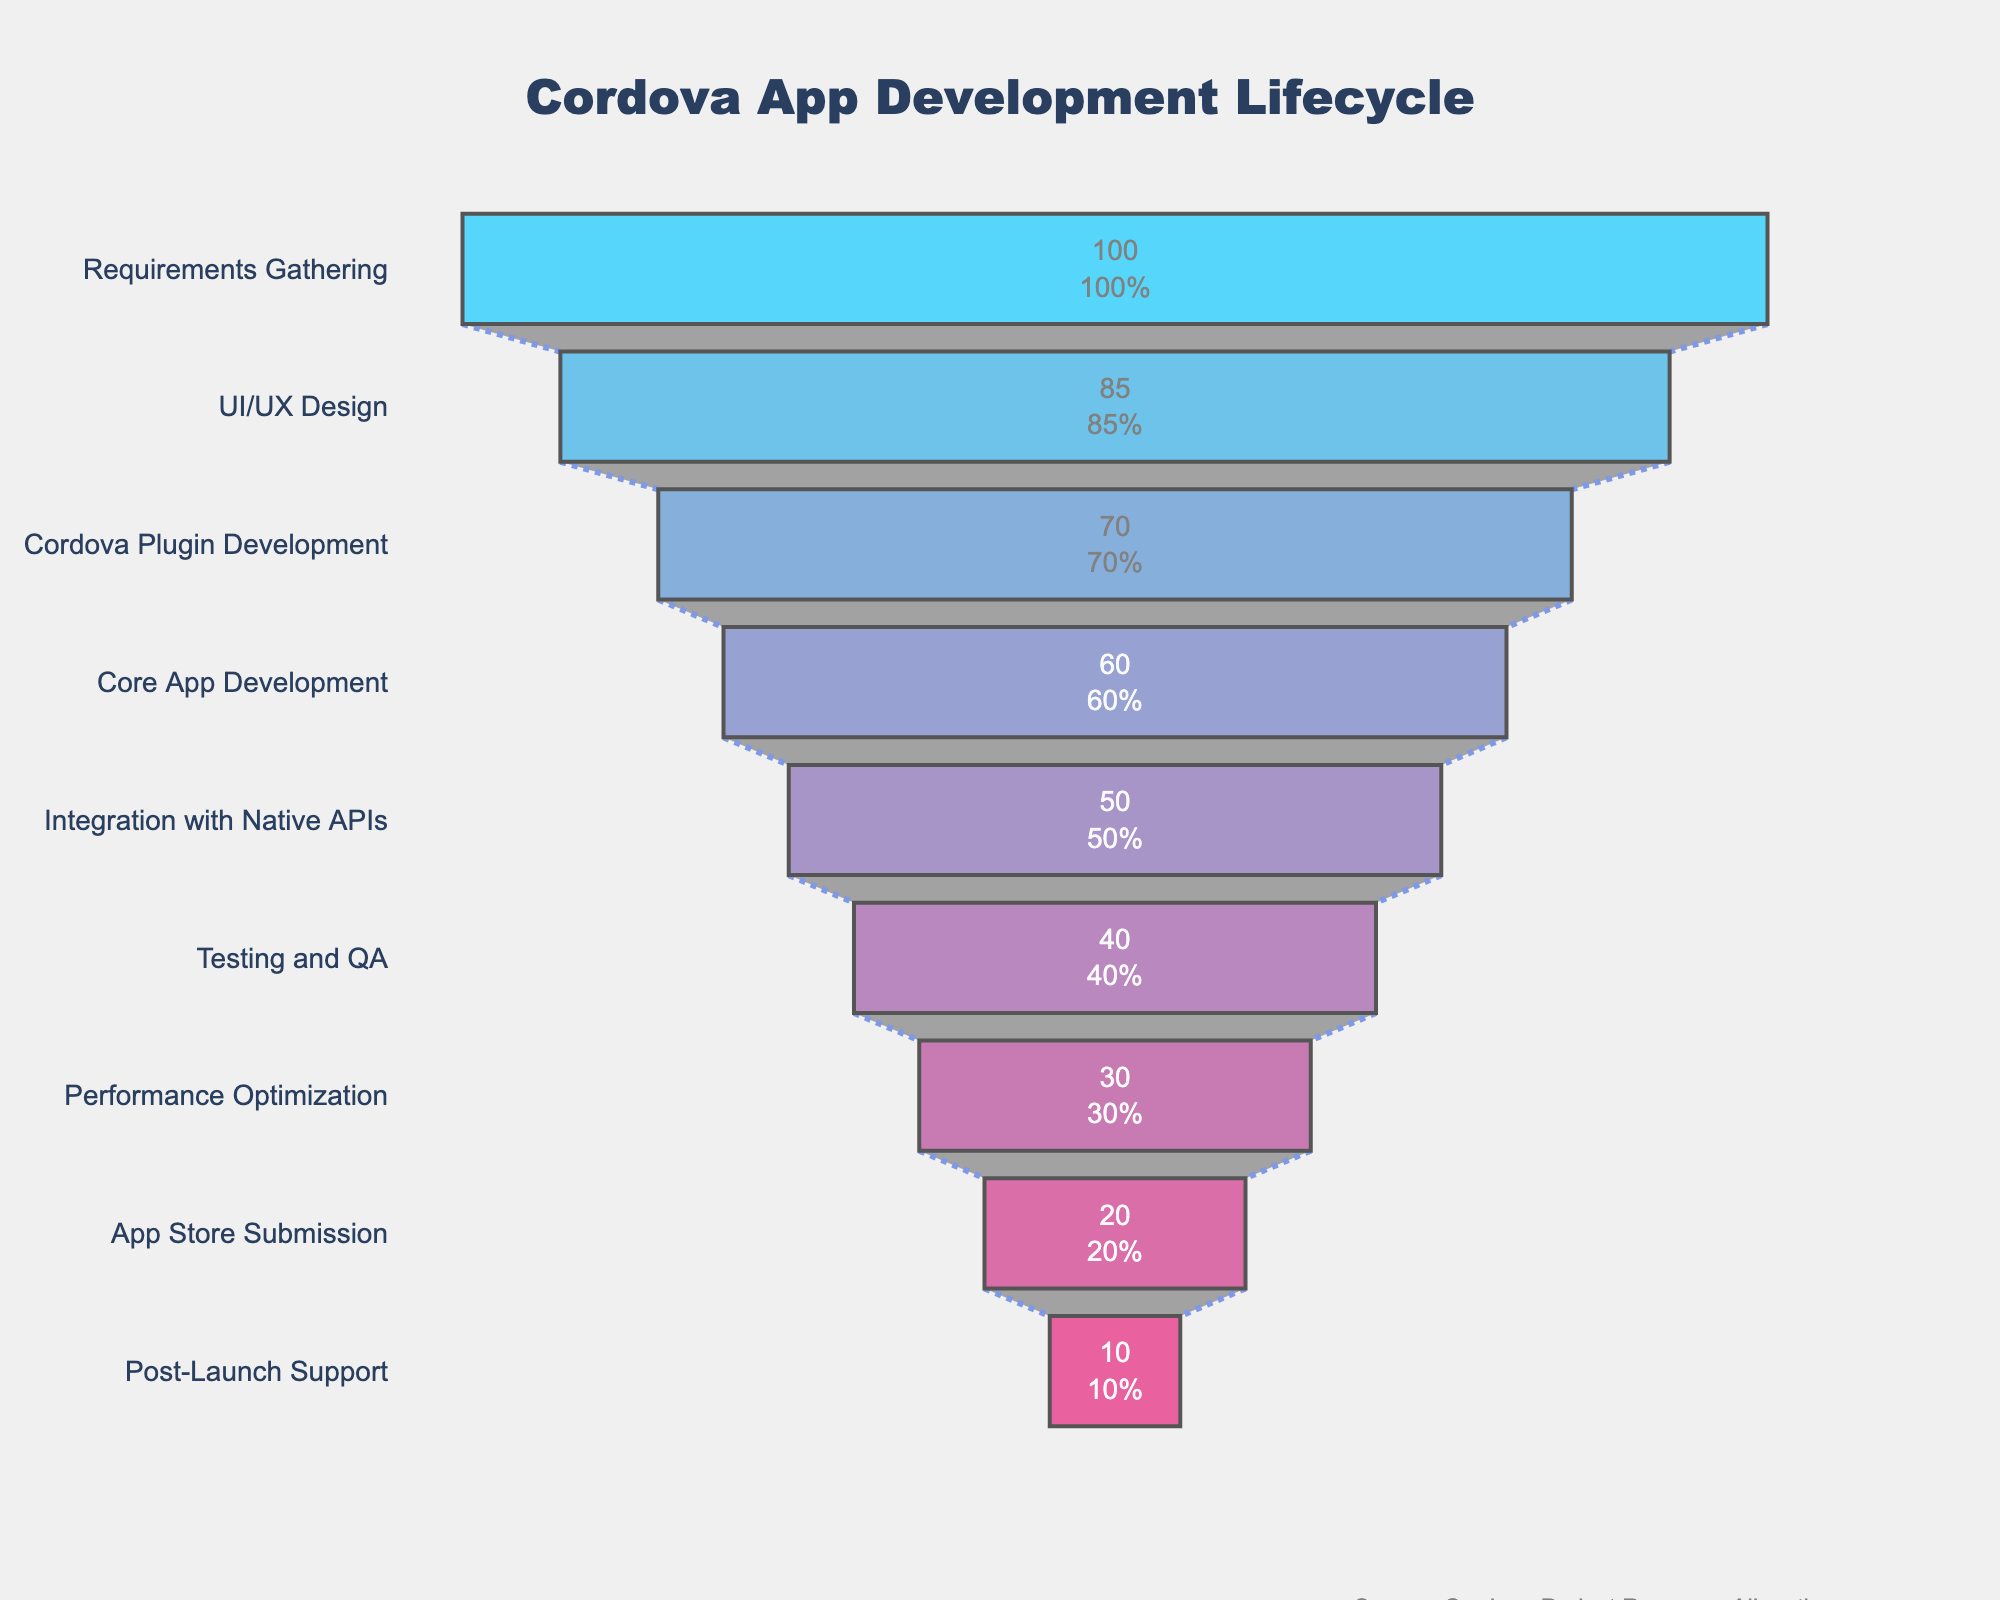What is the title of the funnel chart? The title of the funnel chart is usually prominently displayed at the top. In this case, it is "Cordova App Development Lifecycle"
Answer: Cordova App Development Lifecycle How many stages are represented in the funnel chart? By counting the bars or sections of the funnel chart, you can determine the number of stages. Here, there are 9 stages listed.
Answer: 9 Which stage has the highest resource allocation percentage? The stage with the highest percentage is typically at the top of the funnel. Checking from the top, "Requirements Gathering" has the highest percentage at 100%.
Answer: Requirements Gathering What is the difference in resource allocation between the "Core App Development" and "Integration with Native APIs" stages? The resource allocation for "Core App Development" is 60% and for "Integration with Native APIs" is 50%. The difference can be calculated as 60% - 50% = 10%
Answer: 10% Which stage marks the halfway point in resource allocation reduction from the initial stage? The initial stage starts at 100%. Half of this value is 50%. The stage that has 50% is "Integration with Native APIs"
Answer: Integration with Native APIs What color trend can you observe down the funnel stages? The funnel chart uses colors that change as you move down the stages. The stages towards the top are lighter, and gradually become more intense in color, usually indicating decreased resource allocation.
Answer: Colors become more intense What percentage of resources is allocated for "Testing and QA"? By inspecting the chart, you can see that the "Testing and QA" stage has 40% resource allocation.
Answer: 40% How much total resource allocation is left after the "Requirements Gathering" stage? The stages following "Requirements Gathering" have resource allocations of 85%, 70%, 60%, 50%, 40%, 30%, 20%, and 10%. Adding these up (85 + 70 + 60 + 50 + 40 + 30 + 20 + 10) results in a total of 365%.
Answer: 365% Which two stages have the smallest gap in resource allocation percentages? By inspecting the percentages, the smallest gap is between "Core App Development" (60%) and "Integration with Native APIs" (50%), with a gap of 10%.
Answer: Core App Development and Integration with Native APIs What is the average resource allocation percentage across all stages? Add all percentages together and divide by the number of stages. (100 + 85 + 70 + 60 + 50 + 40 + 30 + 20 + 10) / 9 = 51.67%
Answer: 51.67% 